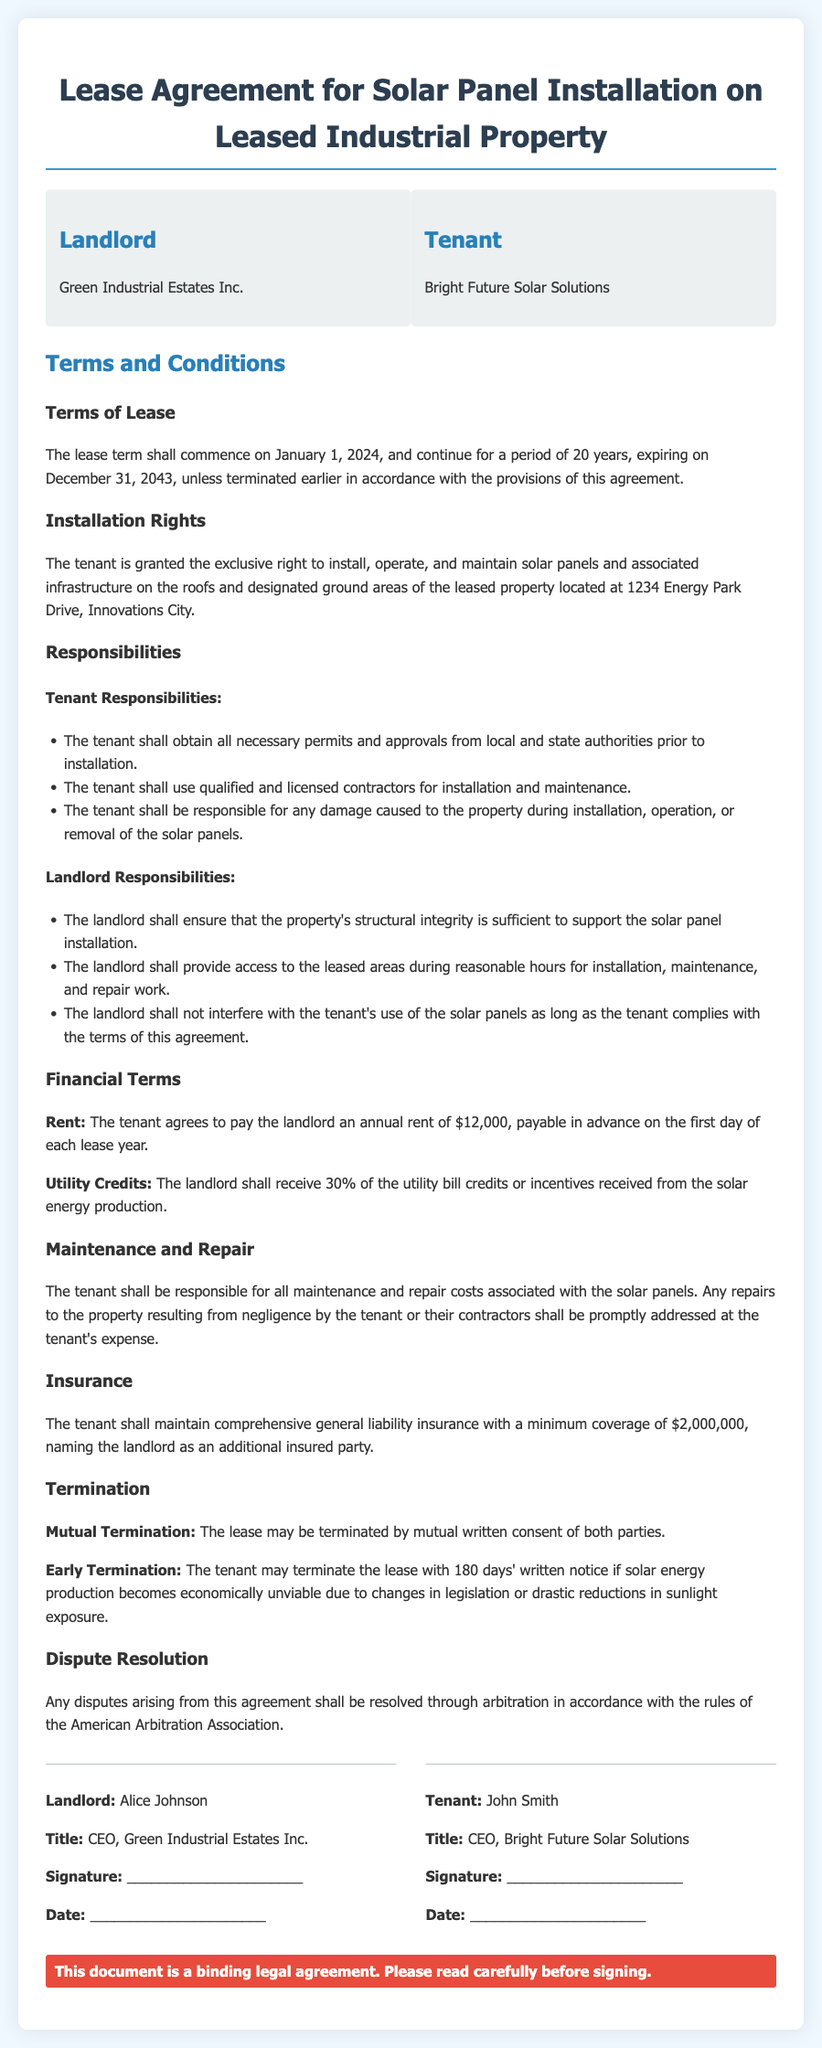What is the name of the landlord? The landlord is identified as Green Industrial Estates Inc.
Answer: Green Industrial Estates Inc What is the annual rent amount? The annual rent is specified in the financial terms section of the document.
Answer: $12,000 When does the lease term commence? The lease commencement date is mentioned under the terms of lease section.
Answer: January 1, 2024 What is the minimum insurance coverage required? The minimum insurance coverage requirement is stated in the insurance section.
Answer: $2,000,000 What percentage of utility credits does the landlord receive? The percentage of credits for utility bills is detailed in the financial terms section.
Answer: 30% What responsibilities does the tenant have for installation? The tenant's obligations regarding installation are listed under tenant responsibilities.
Answer: Obtain all necessary permits How long is the lease term? The duration of the lease term is described in the terms of lease section.
Answer: 20 years Who must be named as an additional insured party? The document specifies who should be named in the insurance coverage.
Answer: The landlord What is required for mutual termination of the lease? The conditions for mutual termination are outlined in the termination section.
Answer: Written consent of both parties 